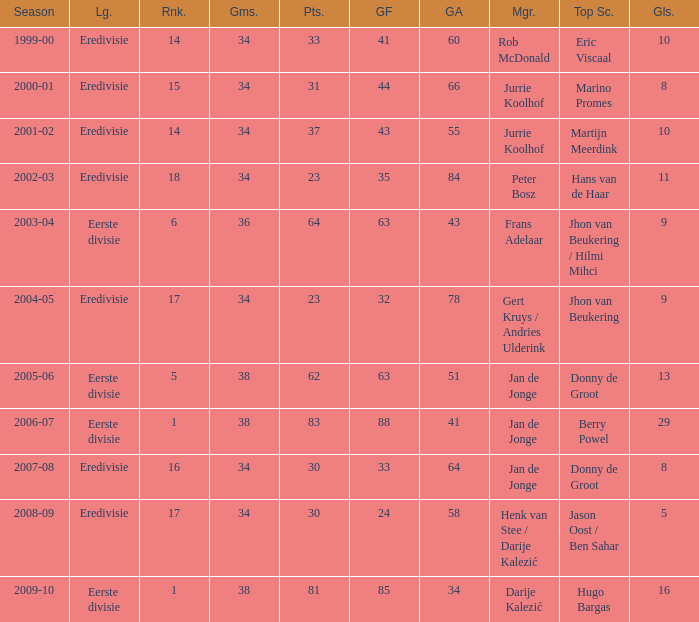How many goals were scored in the 2005-06 season? 13.0. 